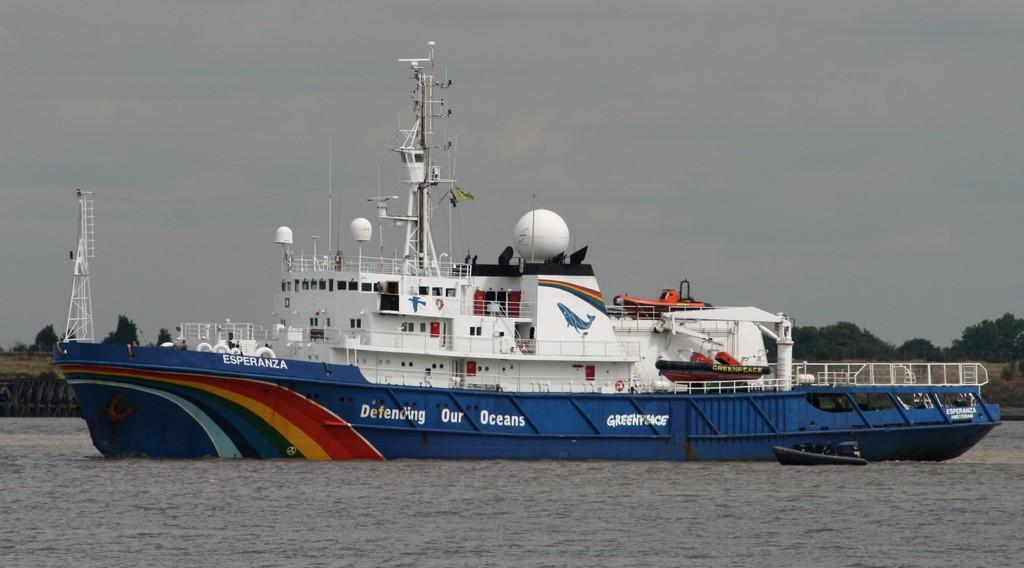<image>
Relay a brief, clear account of the picture shown. the word oceans is on the large and blue vessel 